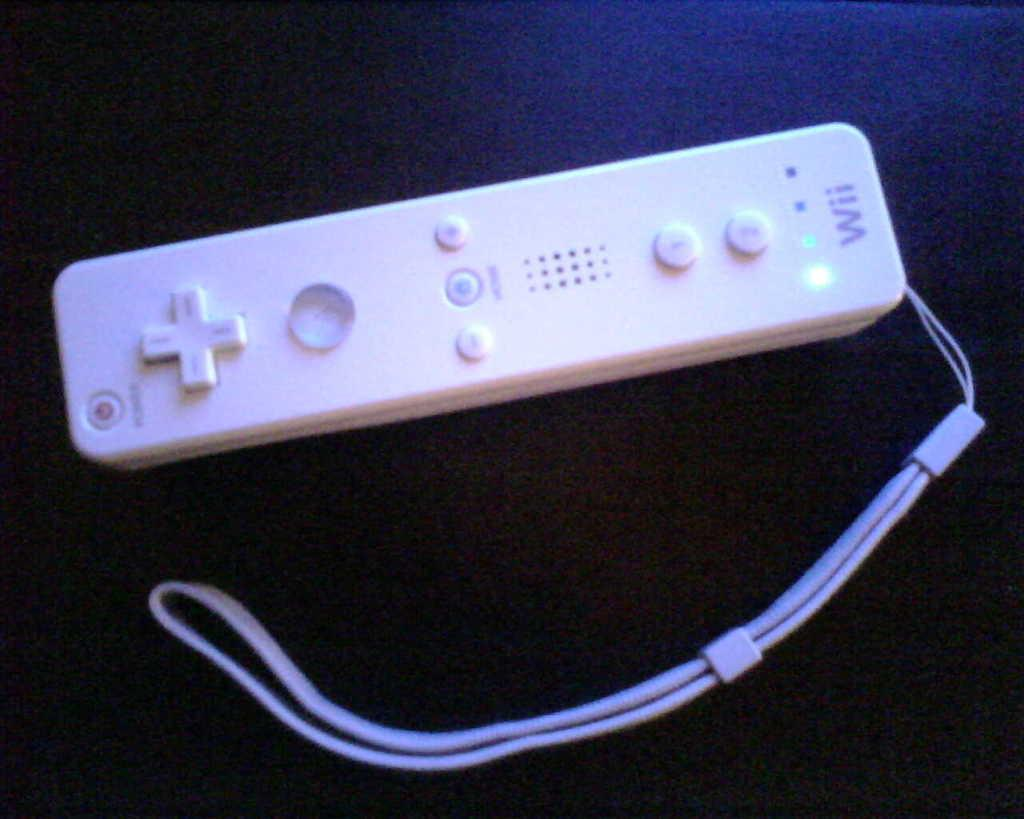<image>
Offer a succinct explanation of the picture presented. A white slim Wii wireless remote controller turned on 